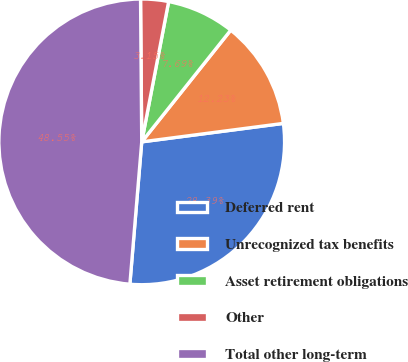Convert chart. <chart><loc_0><loc_0><loc_500><loc_500><pie_chart><fcel>Deferred rent<fcel>Unrecognized tax benefits<fcel>Asset retirement obligations<fcel>Other<fcel>Total other long-term<nl><fcel>28.39%<fcel>12.23%<fcel>7.69%<fcel>3.15%<fcel>48.55%<nl></chart> 